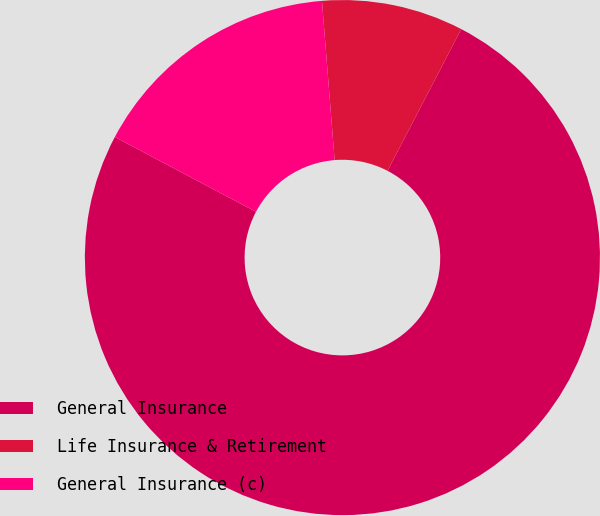Convert chart. <chart><loc_0><loc_0><loc_500><loc_500><pie_chart><fcel>General Insurance<fcel>Life Insurance & Retirement<fcel>General Insurance (c)<nl><fcel>75.13%<fcel>8.9%<fcel>15.98%<nl></chart> 